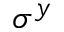<formula> <loc_0><loc_0><loc_500><loc_500>\sigma ^ { y }</formula> 